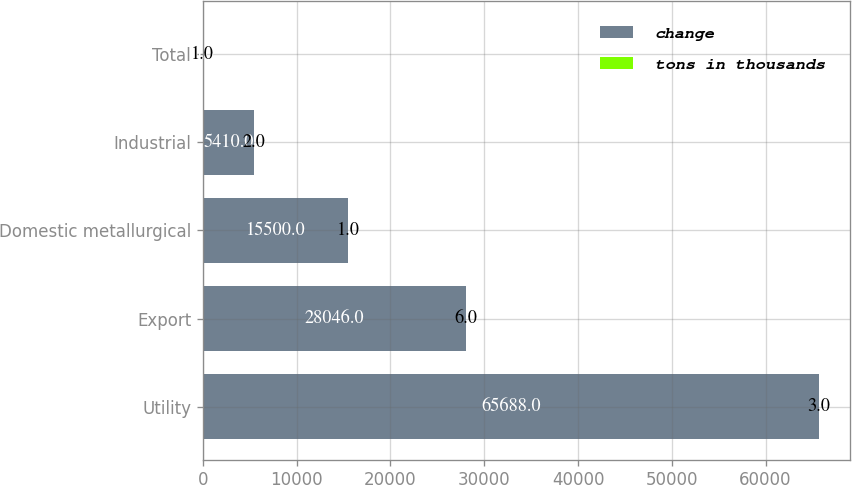Convert chart. <chart><loc_0><loc_0><loc_500><loc_500><stacked_bar_chart><ecel><fcel>Utility<fcel>Export<fcel>Domestic metallurgical<fcel>Industrial<fcel>Total<nl><fcel>change<fcel>65688<fcel>28046<fcel>15500<fcel>5410<fcel>6<nl><fcel>tons in thousands<fcel>3<fcel>6<fcel>1<fcel>2<fcel>1<nl></chart> 